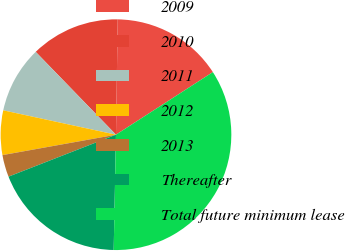Convert chart to OTSL. <chart><loc_0><loc_0><loc_500><loc_500><pie_chart><fcel>2009<fcel>2010<fcel>2011<fcel>2012<fcel>2013<fcel>Thereafter<fcel>Total future minimum lease<nl><fcel>15.63%<fcel>12.49%<fcel>9.36%<fcel>6.22%<fcel>3.09%<fcel>18.76%<fcel>34.44%<nl></chart> 